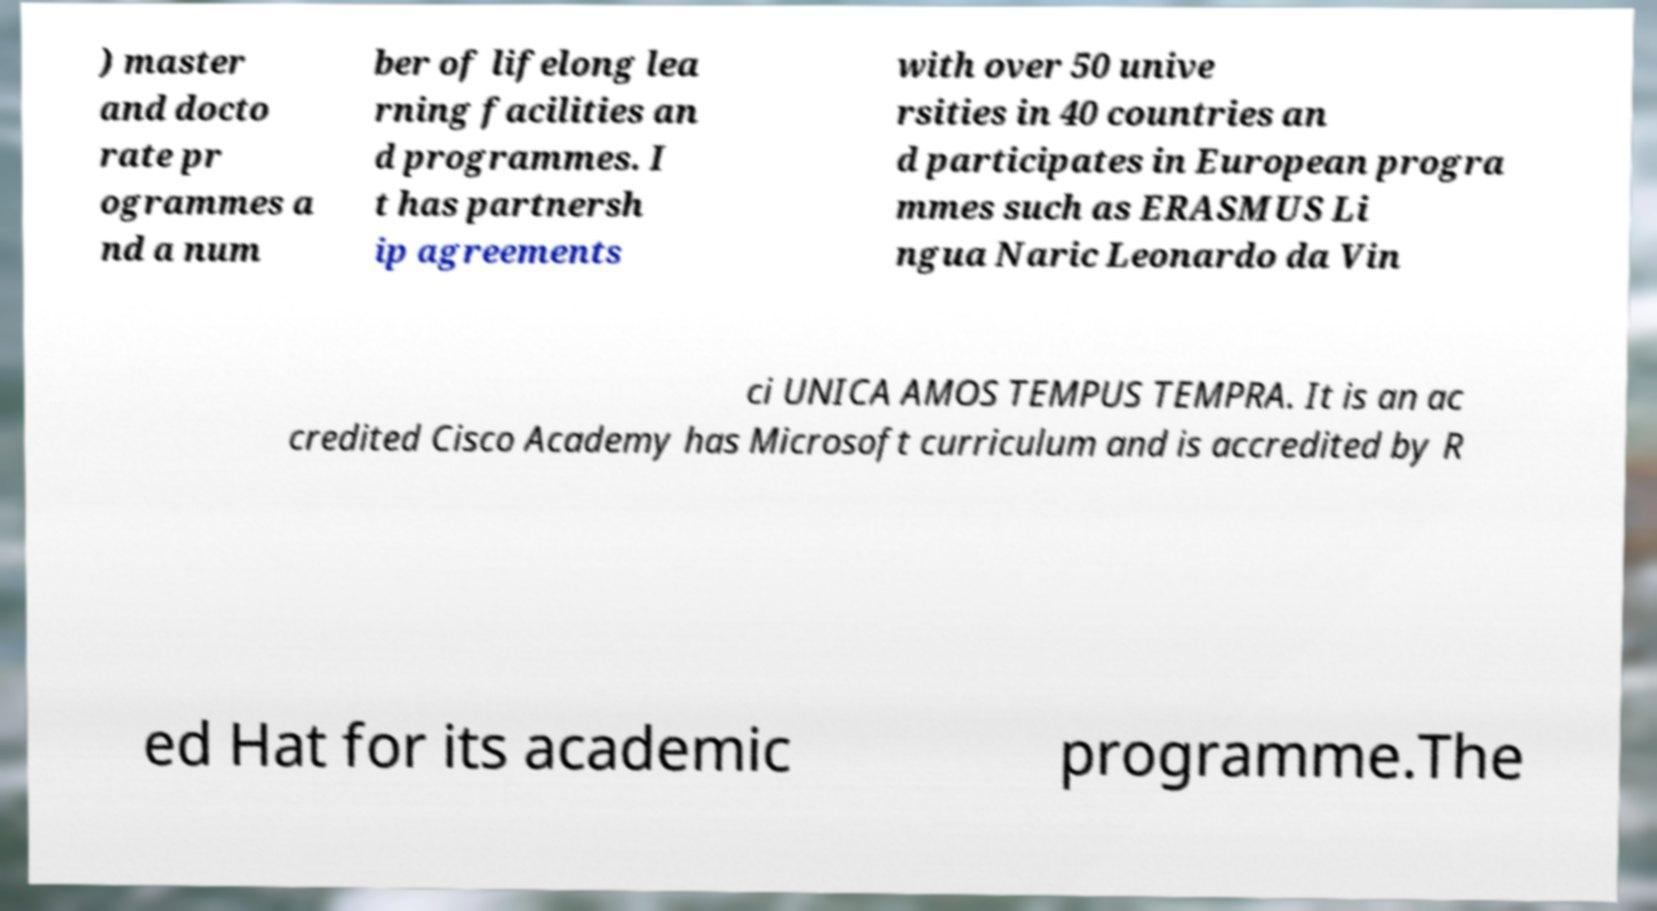Can you read and provide the text displayed in the image?This photo seems to have some interesting text. Can you extract and type it out for me? ) master and docto rate pr ogrammes a nd a num ber of lifelong lea rning facilities an d programmes. I t has partnersh ip agreements with over 50 unive rsities in 40 countries an d participates in European progra mmes such as ERASMUS Li ngua Naric Leonardo da Vin ci UNICA AMOS TEMPUS TEMPRA. It is an ac credited Cisco Academy has Microsoft curriculum and is accredited by R ed Hat for its academic programme.The 